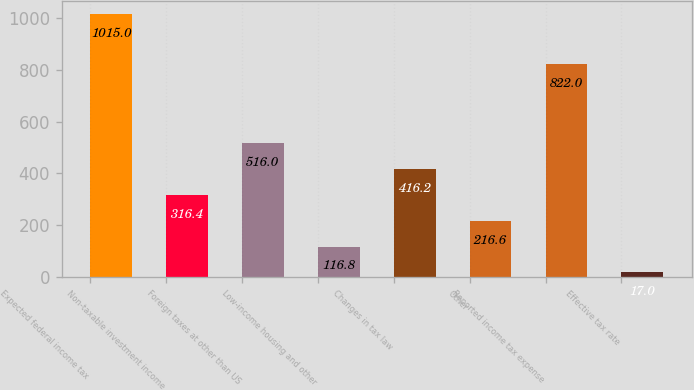Convert chart. <chart><loc_0><loc_0><loc_500><loc_500><bar_chart><fcel>Expected federal income tax<fcel>Non-taxable investment income<fcel>Foreign taxes at other than US<fcel>Low-income housing and other<fcel>Changes in tax law<fcel>Other<fcel>Reported income tax expense<fcel>Effective tax rate<nl><fcel>1015<fcel>316.4<fcel>516<fcel>116.8<fcel>416.2<fcel>216.6<fcel>822<fcel>17<nl></chart> 